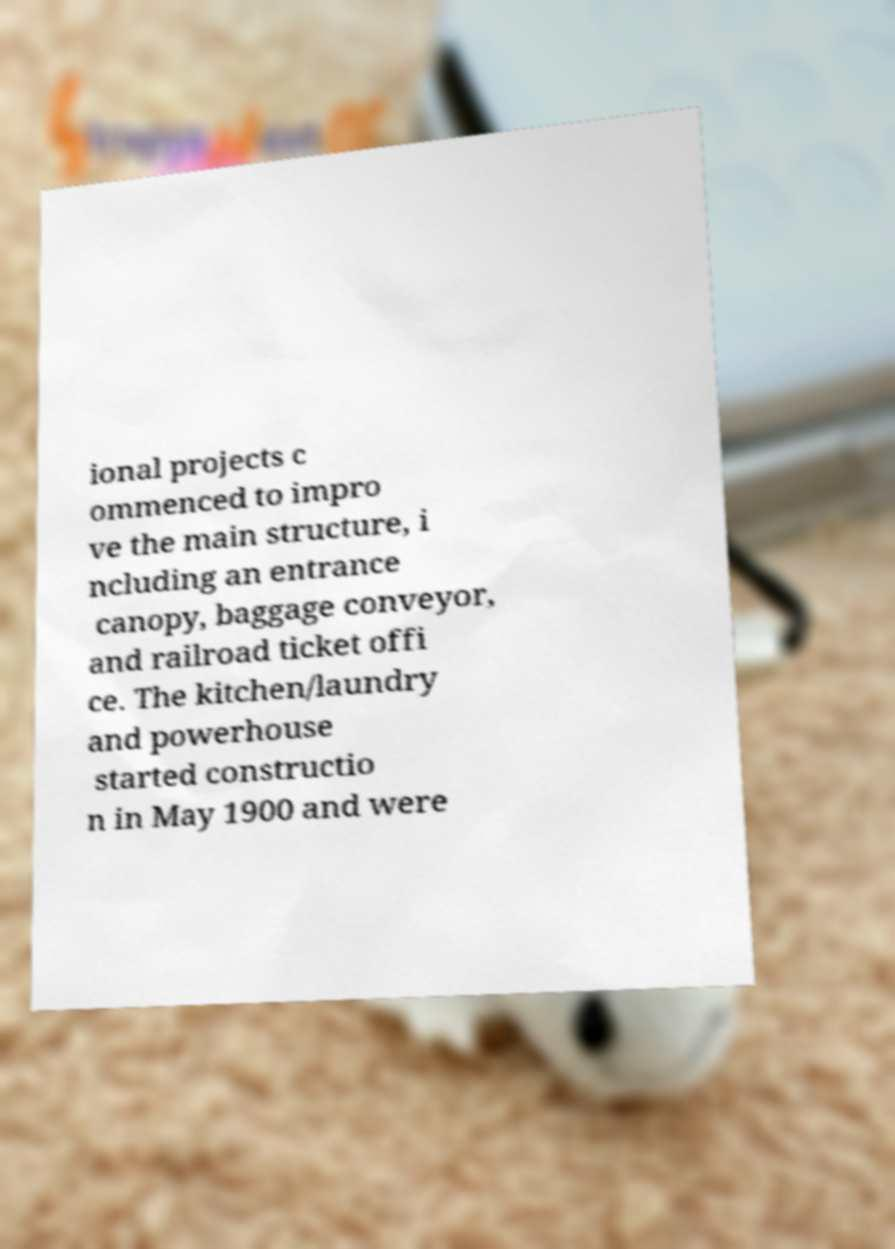For documentation purposes, I need the text within this image transcribed. Could you provide that? ional projects c ommenced to impro ve the main structure, i ncluding an entrance canopy, baggage conveyor, and railroad ticket offi ce. The kitchen/laundry and powerhouse started constructio n in May 1900 and were 